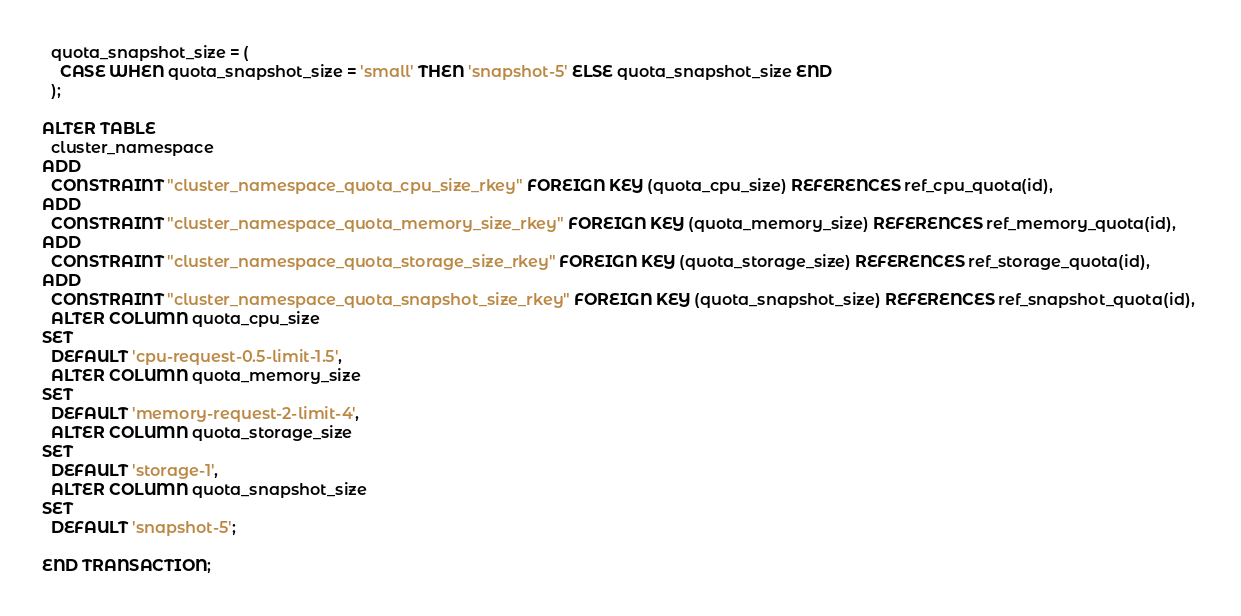Convert code to text. <code><loc_0><loc_0><loc_500><loc_500><_SQL_>  quota_snapshot_size = (
    CASE WHEN quota_snapshot_size = 'small' THEN 'snapshot-5' ELSE quota_snapshot_size END
  );

ALTER TABLE 
  cluster_namespace 
ADD 
  CONSTRAINT "cluster_namespace_quota_cpu_size_rkey" FOREIGN KEY (quota_cpu_size) REFERENCES ref_cpu_quota(id), 
ADD 
  CONSTRAINT "cluster_namespace_quota_memory_size_rkey" FOREIGN KEY (quota_memory_size) REFERENCES ref_memory_quota(id), 
ADD 
  CONSTRAINT "cluster_namespace_quota_storage_size_rkey" FOREIGN KEY (quota_storage_size) REFERENCES ref_storage_quota(id), 
ADD 
  CONSTRAINT "cluster_namespace_quota_snapshot_size_rkey" FOREIGN KEY (quota_snapshot_size) REFERENCES ref_snapshot_quota(id), 
  ALTER COLUMN quota_cpu_size 
SET 
  DEFAULT 'cpu-request-0.5-limit-1.5', 
  ALTER COLUMN quota_memory_size 
SET 
  DEFAULT 'memory-request-2-limit-4', 
  ALTER COLUMN quota_storage_size 
SET 
  DEFAULT 'storage-1', 
  ALTER COLUMN quota_snapshot_size 
SET 
  DEFAULT 'snapshot-5';

END TRANSACTION;
</code> 